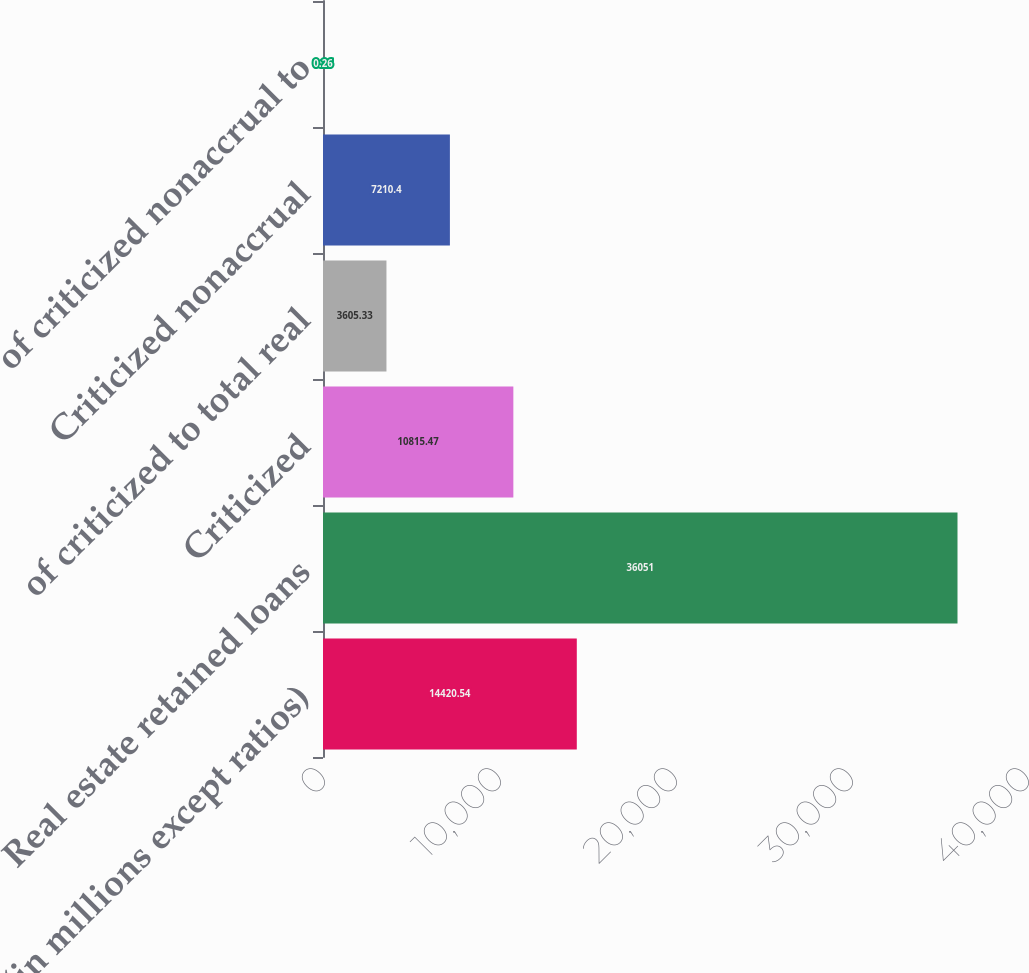Convert chart. <chart><loc_0><loc_0><loc_500><loc_500><bar_chart><fcel>(in millions except ratios)<fcel>Real estate retained loans<fcel>Criticized<fcel>of criticized to total real<fcel>Criticized nonaccrual<fcel>of criticized nonaccrual to<nl><fcel>14420.5<fcel>36051<fcel>10815.5<fcel>3605.33<fcel>7210.4<fcel>0.26<nl></chart> 